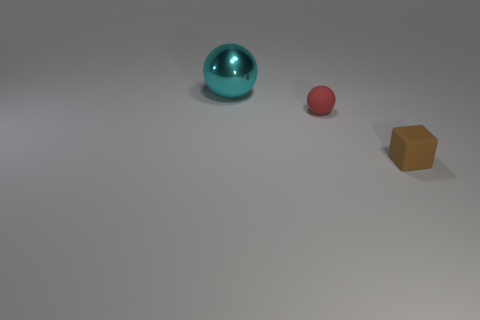Add 2 green matte blocks. How many objects exist? 5 Subtract all blocks. How many objects are left? 2 Add 2 red spheres. How many red spheres are left? 3 Add 2 cyan shiny objects. How many cyan shiny objects exist? 3 Subtract 0 purple cylinders. How many objects are left? 3 Subtract all small brown matte cubes. Subtract all tiny red matte spheres. How many objects are left? 1 